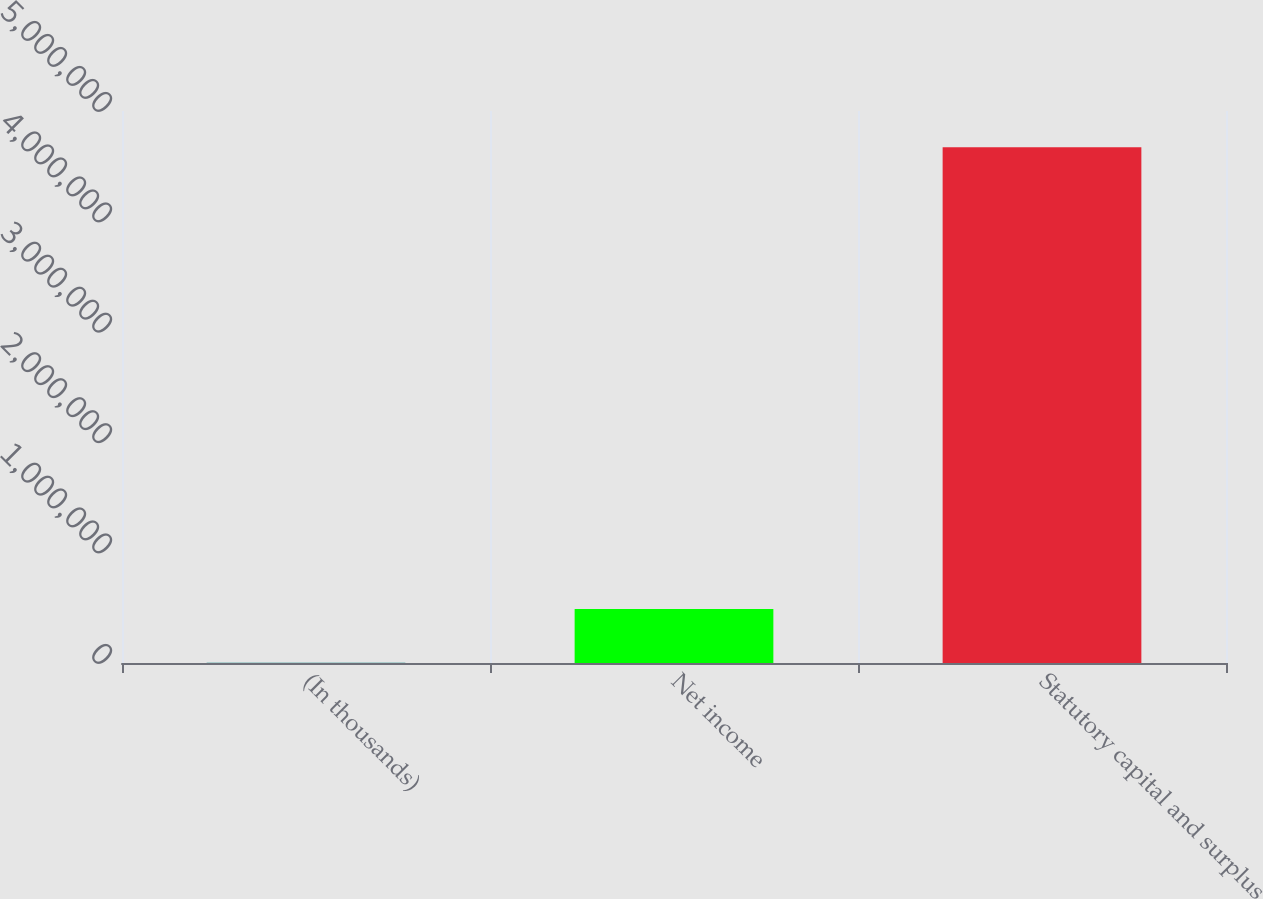<chart> <loc_0><loc_0><loc_500><loc_500><bar_chart><fcel>(In thousands)<fcel>Net income<fcel>Statutory capital and surplus<nl><fcel>2012<fcel>490119<fcel>4.67192e+06<nl></chart> 